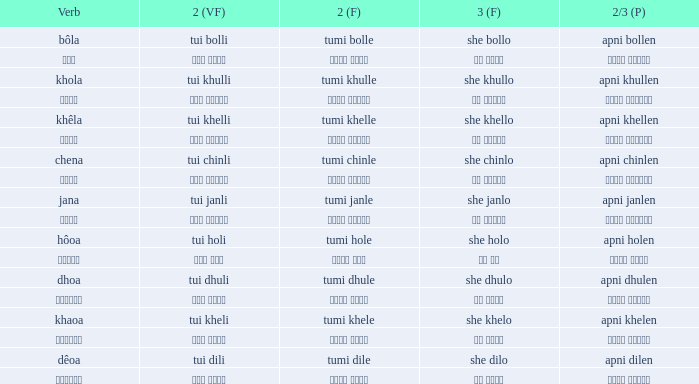What is the second verb associated with khola? Tumi khulle. 